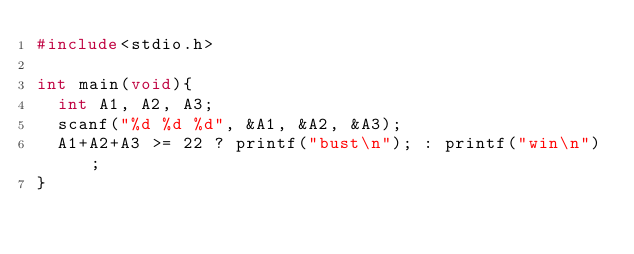<code> <loc_0><loc_0><loc_500><loc_500><_C_>#include<stdio.h>
 
int main(void){
  int A1, A2, A3;
  scanf("%d %d %d", &A1, &A2, &A3);
  A1+A2+A3 >= 22 ? printf("bust\n"); : printf("win\n");
}</code> 